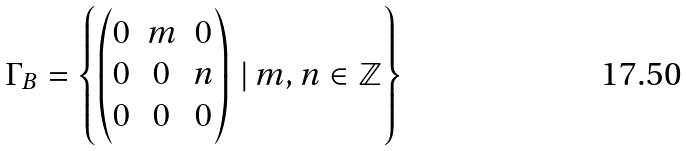Convert formula to latex. <formula><loc_0><loc_0><loc_500><loc_500>\Gamma _ { B } = \left \{ \begin{pmatrix} 0 & m & 0 \\ 0 & 0 & n \\ 0 & 0 & 0 \end{pmatrix} \, | \, m , n \in \mathbb { Z } \right \}</formula> 